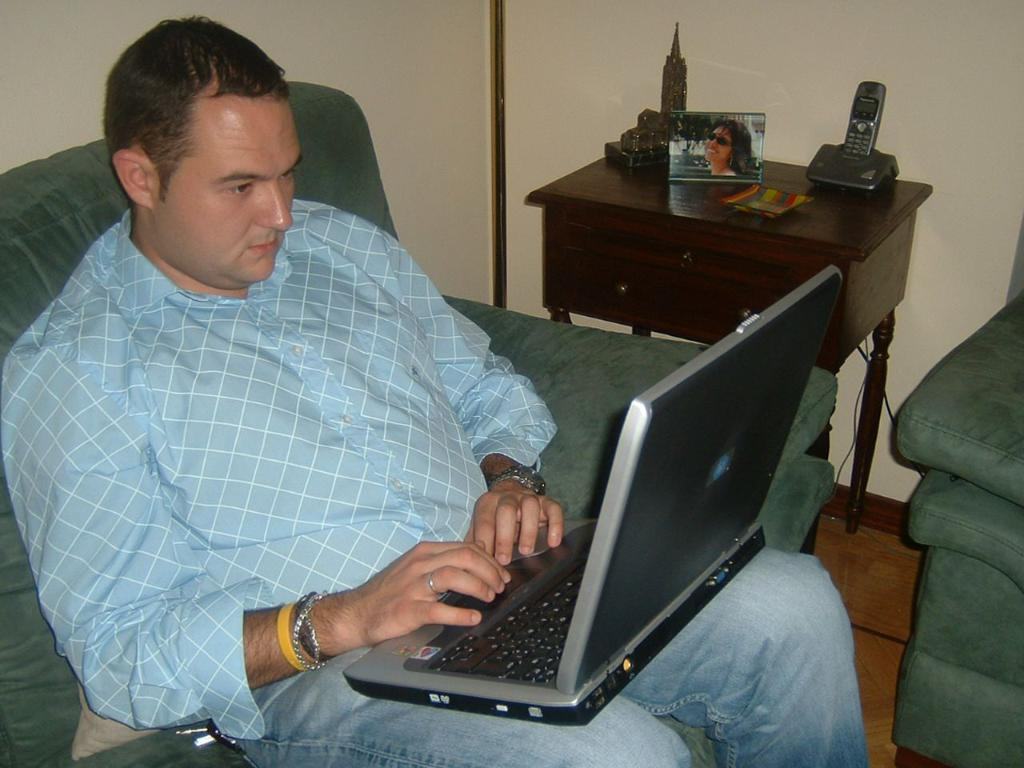What is the man in the image doing? The man is working on a laptop. What is the man sitting on in the image? The man is sitting on a sofa. What can be seen in the background of the image? There is a wall in the background of the image. What type of crow can be seen sitting on the drain in the image? There is no crow or drain present in the image. What message of peace can be seen in the image? There is no message or symbol of peace present in the image. 